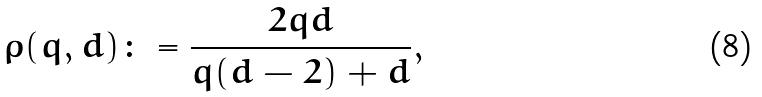<formula> <loc_0><loc_0><loc_500><loc_500>\rho ( q , d ) \colon = \frac { 2 q d } { q ( d - 2 ) + d } ,</formula> 